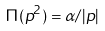<formula> <loc_0><loc_0><loc_500><loc_500>\Pi ( p ^ { 2 } ) = \alpha / | p |</formula> 